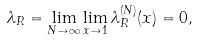<formula> <loc_0><loc_0><loc_500><loc_500>\lambda _ { R } = \lim _ { N \to \infty } \lim _ { x \to 1 } \lambda ^ { ( N ) } _ { R } ( x ) = 0 ,</formula> 